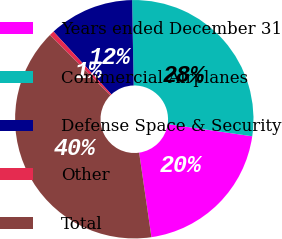Convert chart. <chart><loc_0><loc_0><loc_500><loc_500><pie_chart><fcel>Years ended December 31<fcel>Commercial Airplanes<fcel>Defense Space & Security<fcel>Other<fcel>Total<nl><fcel>20.42%<fcel>27.57%<fcel>11.56%<fcel>0.66%<fcel>39.79%<nl></chart> 